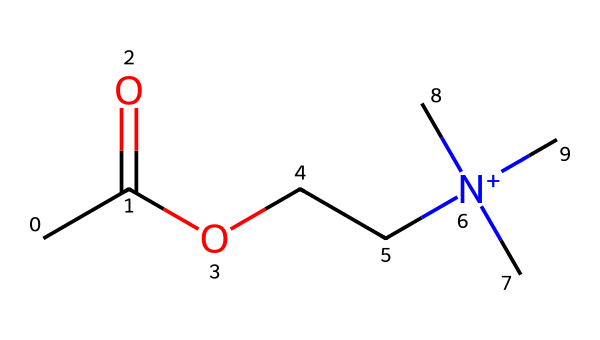What is the molecular formula of acetylcholine? The SMILES representation indicates the arrangement of atoms. Counting the carbon (C), hydrogen (H), oxygen (O), and nitrogen (N) atoms gives us C7H16NO2.
Answer: C7H16NO2 How many carbon atoms are present in acetylcholine? By examining the SMILES, we count the 'C' characters representing carbon atoms in the structure. There are five carbon atoms in the main chain and two in the quaternary ammonium group, totaling seven.
Answer: 7 What type of functional group is present in acetylcholine? The presence of the -OCC- and -N+ groups indicates that acetylcholine possesses an ester and a quaternary amine functional group. The ester is from the -OCC- part and the quaternary amine from the nitrogen with four substituents.
Answer: ester and quaternary amine How many nitrogen atoms does acetylcholine contain? In the SMILES structure, the 'N' character signifies the presence of nitrogen. There is only one nitrogen in the entire molecule.
Answer: 1 What charge does the nitrogen atom have in acetylcholine? The nitrogen in the structure is depicted with four substituents, indicated by the '+' symbol, signifying that it is positively charged due to the quaternary ammonium formation.
Answer: positive Which part of the molecule contributes to its role as a neurotransmitter? The acetylcholine molecule features the nitrogen atom bonded to three methyl groups and one ethyl group, allowing it to interact strongly with receptors in the nervous system, indicating its neurotransmitter role.
Answer: nitrogen atom 